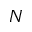Convert formula to latex. <formula><loc_0><loc_0><loc_500><loc_500>N</formula> 